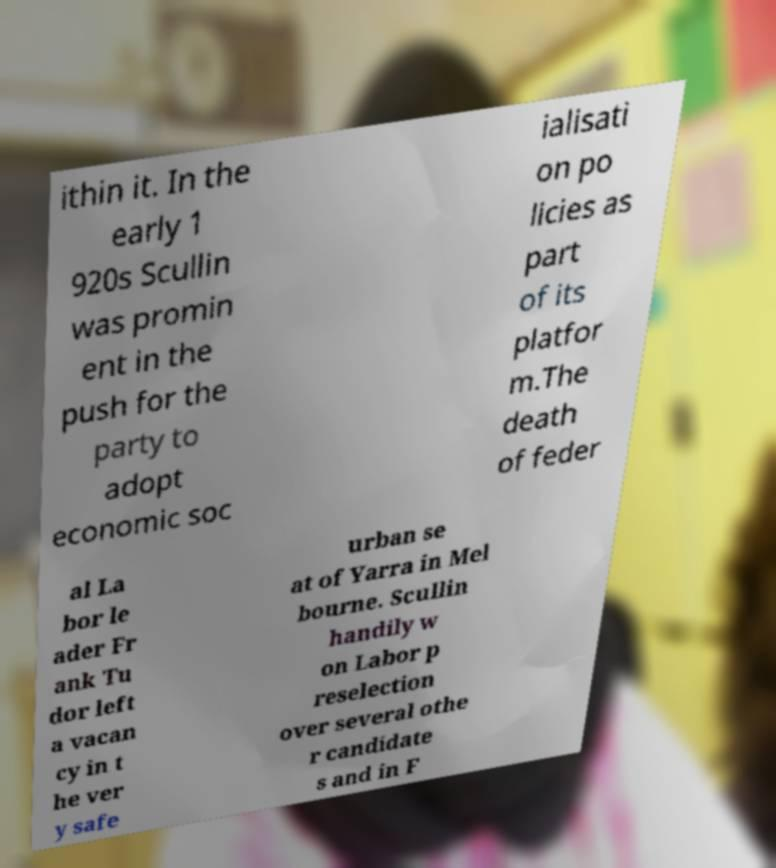Please read and relay the text visible in this image. What does it say? ithin it. In the early 1 920s Scullin was promin ent in the push for the party to adopt economic soc ialisati on po licies as part of its platfor m.The death of feder al La bor le ader Fr ank Tu dor left a vacan cy in t he ver y safe urban se at of Yarra in Mel bourne. Scullin handily w on Labor p reselection over several othe r candidate s and in F 